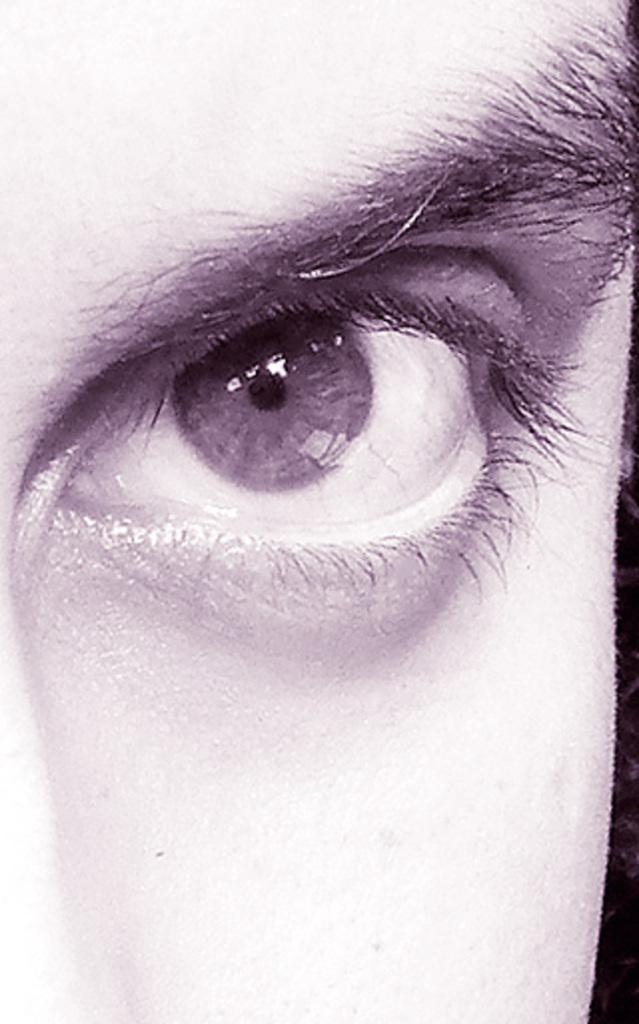Can you describe this image briefly? This is a zoomed in picture. In the center we can see an eye and an eyebrow of a person. On the left corner we can see some portion of the nose. 